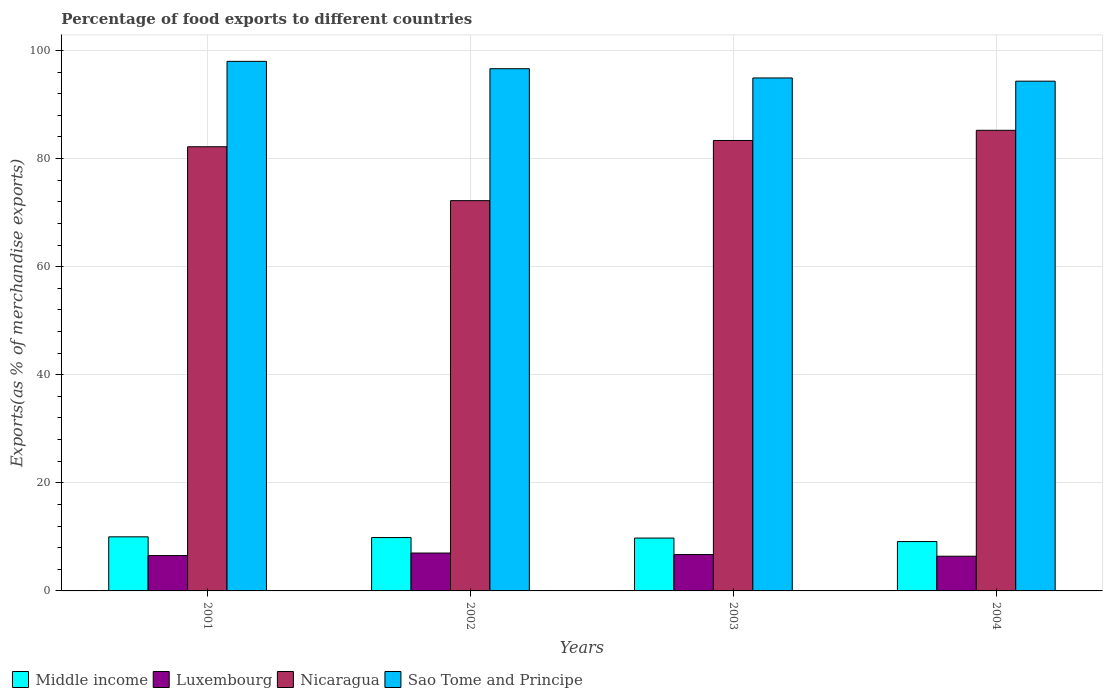How many groups of bars are there?
Provide a succinct answer. 4. Are the number of bars on each tick of the X-axis equal?
Your answer should be compact. Yes. How many bars are there on the 4th tick from the left?
Your answer should be compact. 4. What is the label of the 1st group of bars from the left?
Give a very brief answer. 2001. What is the percentage of exports to different countries in Sao Tome and Principe in 2002?
Provide a short and direct response. 96.63. Across all years, what is the maximum percentage of exports to different countries in Luxembourg?
Make the answer very short. 7.01. Across all years, what is the minimum percentage of exports to different countries in Sao Tome and Principe?
Ensure brevity in your answer.  94.32. What is the total percentage of exports to different countries in Middle income in the graph?
Offer a terse response. 38.79. What is the difference between the percentage of exports to different countries in Nicaragua in 2002 and that in 2004?
Your answer should be compact. -13.02. What is the difference between the percentage of exports to different countries in Middle income in 2001 and the percentage of exports to different countries in Sao Tome and Principe in 2004?
Offer a terse response. -84.31. What is the average percentage of exports to different countries in Luxembourg per year?
Provide a short and direct response. 6.67. In the year 2002, what is the difference between the percentage of exports to different countries in Middle income and percentage of exports to different countries in Sao Tome and Principe?
Offer a very short reply. -86.75. In how many years, is the percentage of exports to different countries in Luxembourg greater than 52 %?
Keep it short and to the point. 0. What is the ratio of the percentage of exports to different countries in Middle income in 2002 to that in 2003?
Ensure brevity in your answer.  1.01. Is the percentage of exports to different countries in Luxembourg in 2003 less than that in 2004?
Your answer should be very brief. No. What is the difference between the highest and the second highest percentage of exports to different countries in Sao Tome and Principe?
Give a very brief answer. 1.36. What is the difference between the highest and the lowest percentage of exports to different countries in Luxembourg?
Your answer should be compact. 0.59. What does the 1st bar from the left in 2004 represents?
Keep it short and to the point. Middle income. What does the 3rd bar from the right in 2003 represents?
Make the answer very short. Luxembourg. Is it the case that in every year, the sum of the percentage of exports to different countries in Luxembourg and percentage of exports to different countries in Nicaragua is greater than the percentage of exports to different countries in Sao Tome and Principe?
Your response must be concise. No. Are all the bars in the graph horizontal?
Offer a very short reply. No. What is the difference between two consecutive major ticks on the Y-axis?
Ensure brevity in your answer.  20. Are the values on the major ticks of Y-axis written in scientific E-notation?
Offer a very short reply. No. Where does the legend appear in the graph?
Keep it short and to the point. Bottom left. How many legend labels are there?
Your answer should be compact. 4. How are the legend labels stacked?
Offer a very short reply. Horizontal. What is the title of the graph?
Make the answer very short. Percentage of food exports to different countries. Does "High income" appear as one of the legend labels in the graph?
Offer a very short reply. No. What is the label or title of the Y-axis?
Provide a succinct answer. Exports(as % of merchandise exports). What is the Exports(as % of merchandise exports) of Middle income in 2001?
Your answer should be very brief. 10.01. What is the Exports(as % of merchandise exports) in Luxembourg in 2001?
Your response must be concise. 6.54. What is the Exports(as % of merchandise exports) of Nicaragua in 2001?
Your response must be concise. 82.19. What is the Exports(as % of merchandise exports) in Sao Tome and Principe in 2001?
Keep it short and to the point. 97.99. What is the Exports(as % of merchandise exports) of Middle income in 2002?
Your response must be concise. 9.87. What is the Exports(as % of merchandise exports) of Luxembourg in 2002?
Ensure brevity in your answer.  7.01. What is the Exports(as % of merchandise exports) in Nicaragua in 2002?
Provide a short and direct response. 72.21. What is the Exports(as % of merchandise exports) in Sao Tome and Principe in 2002?
Offer a terse response. 96.63. What is the Exports(as % of merchandise exports) of Middle income in 2003?
Your answer should be compact. 9.78. What is the Exports(as % of merchandise exports) of Luxembourg in 2003?
Provide a short and direct response. 6.72. What is the Exports(as % of merchandise exports) in Nicaragua in 2003?
Give a very brief answer. 83.35. What is the Exports(as % of merchandise exports) in Sao Tome and Principe in 2003?
Give a very brief answer. 94.92. What is the Exports(as % of merchandise exports) of Middle income in 2004?
Provide a short and direct response. 9.13. What is the Exports(as % of merchandise exports) of Luxembourg in 2004?
Your response must be concise. 6.42. What is the Exports(as % of merchandise exports) in Nicaragua in 2004?
Ensure brevity in your answer.  85.23. What is the Exports(as % of merchandise exports) of Sao Tome and Principe in 2004?
Your response must be concise. 94.32. Across all years, what is the maximum Exports(as % of merchandise exports) in Middle income?
Provide a succinct answer. 10.01. Across all years, what is the maximum Exports(as % of merchandise exports) in Luxembourg?
Make the answer very short. 7.01. Across all years, what is the maximum Exports(as % of merchandise exports) in Nicaragua?
Your answer should be compact. 85.23. Across all years, what is the maximum Exports(as % of merchandise exports) of Sao Tome and Principe?
Offer a very short reply. 97.99. Across all years, what is the minimum Exports(as % of merchandise exports) in Middle income?
Offer a very short reply. 9.13. Across all years, what is the minimum Exports(as % of merchandise exports) of Luxembourg?
Give a very brief answer. 6.42. Across all years, what is the minimum Exports(as % of merchandise exports) of Nicaragua?
Your response must be concise. 72.21. Across all years, what is the minimum Exports(as % of merchandise exports) of Sao Tome and Principe?
Ensure brevity in your answer.  94.32. What is the total Exports(as % of merchandise exports) of Middle income in the graph?
Ensure brevity in your answer.  38.79. What is the total Exports(as % of merchandise exports) in Luxembourg in the graph?
Ensure brevity in your answer.  26.7. What is the total Exports(as % of merchandise exports) in Nicaragua in the graph?
Your response must be concise. 322.98. What is the total Exports(as % of merchandise exports) of Sao Tome and Principe in the graph?
Your response must be concise. 383.86. What is the difference between the Exports(as % of merchandise exports) of Middle income in 2001 and that in 2002?
Ensure brevity in your answer.  0.13. What is the difference between the Exports(as % of merchandise exports) of Luxembourg in 2001 and that in 2002?
Provide a succinct answer. -0.47. What is the difference between the Exports(as % of merchandise exports) in Nicaragua in 2001 and that in 2002?
Ensure brevity in your answer.  9.97. What is the difference between the Exports(as % of merchandise exports) of Sao Tome and Principe in 2001 and that in 2002?
Your answer should be very brief. 1.36. What is the difference between the Exports(as % of merchandise exports) in Middle income in 2001 and that in 2003?
Give a very brief answer. 0.23. What is the difference between the Exports(as % of merchandise exports) in Luxembourg in 2001 and that in 2003?
Your response must be concise. -0.19. What is the difference between the Exports(as % of merchandise exports) in Nicaragua in 2001 and that in 2003?
Ensure brevity in your answer.  -1.16. What is the difference between the Exports(as % of merchandise exports) in Sao Tome and Principe in 2001 and that in 2003?
Keep it short and to the point. 3.07. What is the difference between the Exports(as % of merchandise exports) in Middle income in 2001 and that in 2004?
Ensure brevity in your answer.  0.88. What is the difference between the Exports(as % of merchandise exports) of Luxembourg in 2001 and that in 2004?
Your answer should be very brief. 0.12. What is the difference between the Exports(as % of merchandise exports) of Nicaragua in 2001 and that in 2004?
Make the answer very short. -3.04. What is the difference between the Exports(as % of merchandise exports) of Sao Tome and Principe in 2001 and that in 2004?
Provide a short and direct response. 3.67. What is the difference between the Exports(as % of merchandise exports) in Middle income in 2002 and that in 2003?
Ensure brevity in your answer.  0.1. What is the difference between the Exports(as % of merchandise exports) in Luxembourg in 2002 and that in 2003?
Give a very brief answer. 0.28. What is the difference between the Exports(as % of merchandise exports) of Nicaragua in 2002 and that in 2003?
Your response must be concise. -11.14. What is the difference between the Exports(as % of merchandise exports) of Sao Tome and Principe in 2002 and that in 2003?
Your response must be concise. 1.71. What is the difference between the Exports(as % of merchandise exports) of Middle income in 2002 and that in 2004?
Give a very brief answer. 0.74. What is the difference between the Exports(as % of merchandise exports) of Luxembourg in 2002 and that in 2004?
Your response must be concise. 0.59. What is the difference between the Exports(as % of merchandise exports) in Nicaragua in 2002 and that in 2004?
Keep it short and to the point. -13.02. What is the difference between the Exports(as % of merchandise exports) of Sao Tome and Principe in 2002 and that in 2004?
Your answer should be very brief. 2.31. What is the difference between the Exports(as % of merchandise exports) of Middle income in 2003 and that in 2004?
Give a very brief answer. 0.65. What is the difference between the Exports(as % of merchandise exports) of Luxembourg in 2003 and that in 2004?
Your answer should be compact. 0.3. What is the difference between the Exports(as % of merchandise exports) in Nicaragua in 2003 and that in 2004?
Your answer should be compact. -1.88. What is the difference between the Exports(as % of merchandise exports) of Sao Tome and Principe in 2003 and that in 2004?
Keep it short and to the point. 0.59. What is the difference between the Exports(as % of merchandise exports) of Middle income in 2001 and the Exports(as % of merchandise exports) of Luxembourg in 2002?
Your answer should be very brief. 3. What is the difference between the Exports(as % of merchandise exports) in Middle income in 2001 and the Exports(as % of merchandise exports) in Nicaragua in 2002?
Provide a short and direct response. -62.21. What is the difference between the Exports(as % of merchandise exports) in Middle income in 2001 and the Exports(as % of merchandise exports) in Sao Tome and Principe in 2002?
Offer a terse response. -86.62. What is the difference between the Exports(as % of merchandise exports) in Luxembourg in 2001 and the Exports(as % of merchandise exports) in Nicaragua in 2002?
Keep it short and to the point. -65.67. What is the difference between the Exports(as % of merchandise exports) of Luxembourg in 2001 and the Exports(as % of merchandise exports) of Sao Tome and Principe in 2002?
Keep it short and to the point. -90.09. What is the difference between the Exports(as % of merchandise exports) of Nicaragua in 2001 and the Exports(as % of merchandise exports) of Sao Tome and Principe in 2002?
Your answer should be very brief. -14.44. What is the difference between the Exports(as % of merchandise exports) in Middle income in 2001 and the Exports(as % of merchandise exports) in Luxembourg in 2003?
Make the answer very short. 3.28. What is the difference between the Exports(as % of merchandise exports) in Middle income in 2001 and the Exports(as % of merchandise exports) in Nicaragua in 2003?
Keep it short and to the point. -73.34. What is the difference between the Exports(as % of merchandise exports) in Middle income in 2001 and the Exports(as % of merchandise exports) in Sao Tome and Principe in 2003?
Your answer should be compact. -84.91. What is the difference between the Exports(as % of merchandise exports) of Luxembourg in 2001 and the Exports(as % of merchandise exports) of Nicaragua in 2003?
Provide a succinct answer. -76.81. What is the difference between the Exports(as % of merchandise exports) in Luxembourg in 2001 and the Exports(as % of merchandise exports) in Sao Tome and Principe in 2003?
Offer a terse response. -88.38. What is the difference between the Exports(as % of merchandise exports) of Nicaragua in 2001 and the Exports(as % of merchandise exports) of Sao Tome and Principe in 2003?
Offer a very short reply. -12.73. What is the difference between the Exports(as % of merchandise exports) in Middle income in 2001 and the Exports(as % of merchandise exports) in Luxembourg in 2004?
Provide a short and direct response. 3.59. What is the difference between the Exports(as % of merchandise exports) of Middle income in 2001 and the Exports(as % of merchandise exports) of Nicaragua in 2004?
Provide a short and direct response. -75.22. What is the difference between the Exports(as % of merchandise exports) in Middle income in 2001 and the Exports(as % of merchandise exports) in Sao Tome and Principe in 2004?
Provide a succinct answer. -84.31. What is the difference between the Exports(as % of merchandise exports) in Luxembourg in 2001 and the Exports(as % of merchandise exports) in Nicaragua in 2004?
Offer a very short reply. -78.69. What is the difference between the Exports(as % of merchandise exports) of Luxembourg in 2001 and the Exports(as % of merchandise exports) of Sao Tome and Principe in 2004?
Ensure brevity in your answer.  -87.78. What is the difference between the Exports(as % of merchandise exports) of Nicaragua in 2001 and the Exports(as % of merchandise exports) of Sao Tome and Principe in 2004?
Offer a terse response. -12.14. What is the difference between the Exports(as % of merchandise exports) of Middle income in 2002 and the Exports(as % of merchandise exports) of Luxembourg in 2003?
Give a very brief answer. 3.15. What is the difference between the Exports(as % of merchandise exports) in Middle income in 2002 and the Exports(as % of merchandise exports) in Nicaragua in 2003?
Give a very brief answer. -73.47. What is the difference between the Exports(as % of merchandise exports) in Middle income in 2002 and the Exports(as % of merchandise exports) in Sao Tome and Principe in 2003?
Provide a succinct answer. -85.04. What is the difference between the Exports(as % of merchandise exports) of Luxembourg in 2002 and the Exports(as % of merchandise exports) of Nicaragua in 2003?
Provide a short and direct response. -76.34. What is the difference between the Exports(as % of merchandise exports) in Luxembourg in 2002 and the Exports(as % of merchandise exports) in Sao Tome and Principe in 2003?
Your answer should be compact. -87.91. What is the difference between the Exports(as % of merchandise exports) of Nicaragua in 2002 and the Exports(as % of merchandise exports) of Sao Tome and Principe in 2003?
Provide a short and direct response. -22.7. What is the difference between the Exports(as % of merchandise exports) in Middle income in 2002 and the Exports(as % of merchandise exports) in Luxembourg in 2004?
Give a very brief answer. 3.45. What is the difference between the Exports(as % of merchandise exports) in Middle income in 2002 and the Exports(as % of merchandise exports) in Nicaragua in 2004?
Keep it short and to the point. -75.36. What is the difference between the Exports(as % of merchandise exports) in Middle income in 2002 and the Exports(as % of merchandise exports) in Sao Tome and Principe in 2004?
Keep it short and to the point. -84.45. What is the difference between the Exports(as % of merchandise exports) of Luxembourg in 2002 and the Exports(as % of merchandise exports) of Nicaragua in 2004?
Your answer should be very brief. -78.22. What is the difference between the Exports(as % of merchandise exports) of Luxembourg in 2002 and the Exports(as % of merchandise exports) of Sao Tome and Principe in 2004?
Your response must be concise. -87.31. What is the difference between the Exports(as % of merchandise exports) in Nicaragua in 2002 and the Exports(as % of merchandise exports) in Sao Tome and Principe in 2004?
Ensure brevity in your answer.  -22.11. What is the difference between the Exports(as % of merchandise exports) of Middle income in 2003 and the Exports(as % of merchandise exports) of Luxembourg in 2004?
Your answer should be compact. 3.36. What is the difference between the Exports(as % of merchandise exports) in Middle income in 2003 and the Exports(as % of merchandise exports) in Nicaragua in 2004?
Ensure brevity in your answer.  -75.45. What is the difference between the Exports(as % of merchandise exports) in Middle income in 2003 and the Exports(as % of merchandise exports) in Sao Tome and Principe in 2004?
Your answer should be compact. -84.54. What is the difference between the Exports(as % of merchandise exports) in Luxembourg in 2003 and the Exports(as % of merchandise exports) in Nicaragua in 2004?
Offer a very short reply. -78.51. What is the difference between the Exports(as % of merchandise exports) in Luxembourg in 2003 and the Exports(as % of merchandise exports) in Sao Tome and Principe in 2004?
Ensure brevity in your answer.  -87.6. What is the difference between the Exports(as % of merchandise exports) in Nicaragua in 2003 and the Exports(as % of merchandise exports) in Sao Tome and Principe in 2004?
Your answer should be compact. -10.97. What is the average Exports(as % of merchandise exports) in Middle income per year?
Offer a very short reply. 9.7. What is the average Exports(as % of merchandise exports) in Luxembourg per year?
Offer a terse response. 6.67. What is the average Exports(as % of merchandise exports) of Nicaragua per year?
Make the answer very short. 80.74. What is the average Exports(as % of merchandise exports) of Sao Tome and Principe per year?
Your response must be concise. 95.96. In the year 2001, what is the difference between the Exports(as % of merchandise exports) in Middle income and Exports(as % of merchandise exports) in Luxembourg?
Keep it short and to the point. 3.47. In the year 2001, what is the difference between the Exports(as % of merchandise exports) of Middle income and Exports(as % of merchandise exports) of Nicaragua?
Keep it short and to the point. -72.18. In the year 2001, what is the difference between the Exports(as % of merchandise exports) in Middle income and Exports(as % of merchandise exports) in Sao Tome and Principe?
Offer a very short reply. -87.98. In the year 2001, what is the difference between the Exports(as % of merchandise exports) of Luxembourg and Exports(as % of merchandise exports) of Nicaragua?
Offer a terse response. -75.65. In the year 2001, what is the difference between the Exports(as % of merchandise exports) of Luxembourg and Exports(as % of merchandise exports) of Sao Tome and Principe?
Ensure brevity in your answer.  -91.45. In the year 2001, what is the difference between the Exports(as % of merchandise exports) of Nicaragua and Exports(as % of merchandise exports) of Sao Tome and Principe?
Provide a succinct answer. -15.8. In the year 2002, what is the difference between the Exports(as % of merchandise exports) in Middle income and Exports(as % of merchandise exports) in Luxembourg?
Offer a terse response. 2.86. In the year 2002, what is the difference between the Exports(as % of merchandise exports) in Middle income and Exports(as % of merchandise exports) in Nicaragua?
Ensure brevity in your answer.  -62.34. In the year 2002, what is the difference between the Exports(as % of merchandise exports) of Middle income and Exports(as % of merchandise exports) of Sao Tome and Principe?
Offer a very short reply. -86.75. In the year 2002, what is the difference between the Exports(as % of merchandise exports) in Luxembourg and Exports(as % of merchandise exports) in Nicaragua?
Ensure brevity in your answer.  -65.2. In the year 2002, what is the difference between the Exports(as % of merchandise exports) of Luxembourg and Exports(as % of merchandise exports) of Sao Tome and Principe?
Your response must be concise. -89.62. In the year 2002, what is the difference between the Exports(as % of merchandise exports) in Nicaragua and Exports(as % of merchandise exports) in Sao Tome and Principe?
Provide a short and direct response. -24.41. In the year 2003, what is the difference between the Exports(as % of merchandise exports) in Middle income and Exports(as % of merchandise exports) in Luxembourg?
Provide a succinct answer. 3.05. In the year 2003, what is the difference between the Exports(as % of merchandise exports) of Middle income and Exports(as % of merchandise exports) of Nicaragua?
Give a very brief answer. -73.57. In the year 2003, what is the difference between the Exports(as % of merchandise exports) of Middle income and Exports(as % of merchandise exports) of Sao Tome and Principe?
Provide a short and direct response. -85.14. In the year 2003, what is the difference between the Exports(as % of merchandise exports) in Luxembourg and Exports(as % of merchandise exports) in Nicaragua?
Offer a very short reply. -76.62. In the year 2003, what is the difference between the Exports(as % of merchandise exports) of Luxembourg and Exports(as % of merchandise exports) of Sao Tome and Principe?
Your answer should be very brief. -88.19. In the year 2003, what is the difference between the Exports(as % of merchandise exports) in Nicaragua and Exports(as % of merchandise exports) in Sao Tome and Principe?
Offer a very short reply. -11.57. In the year 2004, what is the difference between the Exports(as % of merchandise exports) of Middle income and Exports(as % of merchandise exports) of Luxembourg?
Ensure brevity in your answer.  2.71. In the year 2004, what is the difference between the Exports(as % of merchandise exports) in Middle income and Exports(as % of merchandise exports) in Nicaragua?
Provide a short and direct response. -76.1. In the year 2004, what is the difference between the Exports(as % of merchandise exports) in Middle income and Exports(as % of merchandise exports) in Sao Tome and Principe?
Give a very brief answer. -85.19. In the year 2004, what is the difference between the Exports(as % of merchandise exports) of Luxembourg and Exports(as % of merchandise exports) of Nicaragua?
Offer a terse response. -78.81. In the year 2004, what is the difference between the Exports(as % of merchandise exports) of Luxembourg and Exports(as % of merchandise exports) of Sao Tome and Principe?
Provide a succinct answer. -87.9. In the year 2004, what is the difference between the Exports(as % of merchandise exports) in Nicaragua and Exports(as % of merchandise exports) in Sao Tome and Principe?
Your answer should be compact. -9.09. What is the ratio of the Exports(as % of merchandise exports) in Middle income in 2001 to that in 2002?
Keep it short and to the point. 1.01. What is the ratio of the Exports(as % of merchandise exports) in Luxembourg in 2001 to that in 2002?
Give a very brief answer. 0.93. What is the ratio of the Exports(as % of merchandise exports) in Nicaragua in 2001 to that in 2002?
Your answer should be compact. 1.14. What is the ratio of the Exports(as % of merchandise exports) of Sao Tome and Principe in 2001 to that in 2002?
Make the answer very short. 1.01. What is the ratio of the Exports(as % of merchandise exports) of Middle income in 2001 to that in 2003?
Provide a succinct answer. 1.02. What is the ratio of the Exports(as % of merchandise exports) of Luxembourg in 2001 to that in 2003?
Offer a terse response. 0.97. What is the ratio of the Exports(as % of merchandise exports) in Nicaragua in 2001 to that in 2003?
Ensure brevity in your answer.  0.99. What is the ratio of the Exports(as % of merchandise exports) of Sao Tome and Principe in 2001 to that in 2003?
Give a very brief answer. 1.03. What is the ratio of the Exports(as % of merchandise exports) in Middle income in 2001 to that in 2004?
Offer a terse response. 1.1. What is the ratio of the Exports(as % of merchandise exports) of Luxembourg in 2001 to that in 2004?
Give a very brief answer. 1.02. What is the ratio of the Exports(as % of merchandise exports) in Sao Tome and Principe in 2001 to that in 2004?
Offer a terse response. 1.04. What is the ratio of the Exports(as % of merchandise exports) in Middle income in 2002 to that in 2003?
Offer a very short reply. 1.01. What is the ratio of the Exports(as % of merchandise exports) in Luxembourg in 2002 to that in 2003?
Keep it short and to the point. 1.04. What is the ratio of the Exports(as % of merchandise exports) in Nicaragua in 2002 to that in 2003?
Ensure brevity in your answer.  0.87. What is the ratio of the Exports(as % of merchandise exports) in Sao Tome and Principe in 2002 to that in 2003?
Your answer should be very brief. 1.02. What is the ratio of the Exports(as % of merchandise exports) in Middle income in 2002 to that in 2004?
Give a very brief answer. 1.08. What is the ratio of the Exports(as % of merchandise exports) of Luxembourg in 2002 to that in 2004?
Your response must be concise. 1.09. What is the ratio of the Exports(as % of merchandise exports) in Nicaragua in 2002 to that in 2004?
Your response must be concise. 0.85. What is the ratio of the Exports(as % of merchandise exports) in Sao Tome and Principe in 2002 to that in 2004?
Ensure brevity in your answer.  1.02. What is the ratio of the Exports(as % of merchandise exports) of Middle income in 2003 to that in 2004?
Make the answer very short. 1.07. What is the ratio of the Exports(as % of merchandise exports) in Luxembourg in 2003 to that in 2004?
Ensure brevity in your answer.  1.05. What is the ratio of the Exports(as % of merchandise exports) of Nicaragua in 2003 to that in 2004?
Make the answer very short. 0.98. What is the difference between the highest and the second highest Exports(as % of merchandise exports) in Middle income?
Give a very brief answer. 0.13. What is the difference between the highest and the second highest Exports(as % of merchandise exports) in Luxembourg?
Give a very brief answer. 0.28. What is the difference between the highest and the second highest Exports(as % of merchandise exports) of Nicaragua?
Ensure brevity in your answer.  1.88. What is the difference between the highest and the second highest Exports(as % of merchandise exports) of Sao Tome and Principe?
Your answer should be compact. 1.36. What is the difference between the highest and the lowest Exports(as % of merchandise exports) of Middle income?
Provide a succinct answer. 0.88. What is the difference between the highest and the lowest Exports(as % of merchandise exports) in Luxembourg?
Offer a very short reply. 0.59. What is the difference between the highest and the lowest Exports(as % of merchandise exports) in Nicaragua?
Offer a terse response. 13.02. What is the difference between the highest and the lowest Exports(as % of merchandise exports) of Sao Tome and Principe?
Provide a short and direct response. 3.67. 